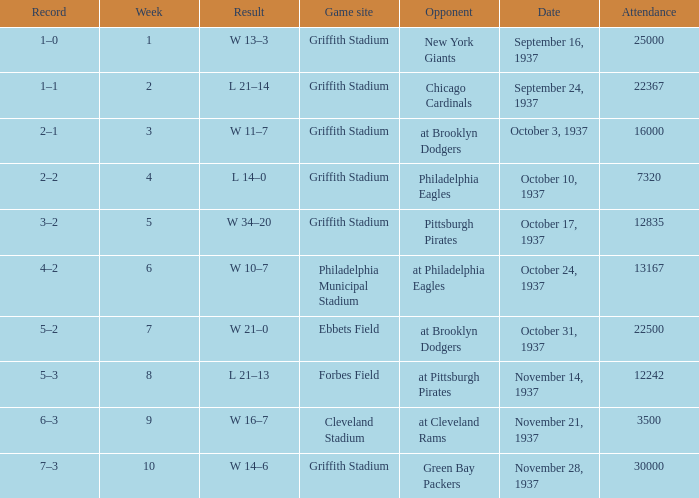What are week 4 results?  L 14–0. 